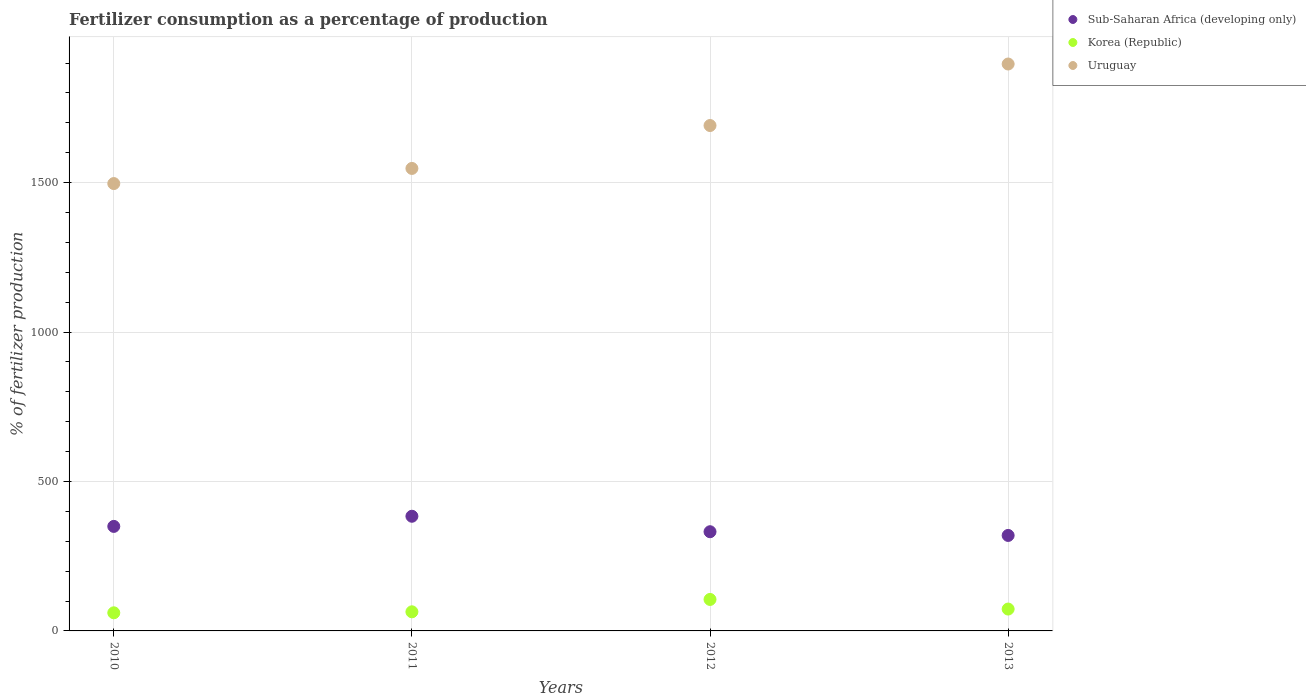Is the number of dotlines equal to the number of legend labels?
Provide a succinct answer. Yes. What is the percentage of fertilizers consumed in Sub-Saharan Africa (developing only) in 2010?
Your response must be concise. 349.74. Across all years, what is the maximum percentage of fertilizers consumed in Korea (Republic)?
Provide a short and direct response. 105.33. Across all years, what is the minimum percentage of fertilizers consumed in Uruguay?
Your response must be concise. 1496.86. In which year was the percentage of fertilizers consumed in Sub-Saharan Africa (developing only) maximum?
Offer a very short reply. 2011. What is the total percentage of fertilizers consumed in Korea (Republic) in the graph?
Your answer should be compact. 303.06. What is the difference between the percentage of fertilizers consumed in Sub-Saharan Africa (developing only) in 2011 and that in 2013?
Provide a succinct answer. 64.2. What is the difference between the percentage of fertilizers consumed in Korea (Republic) in 2013 and the percentage of fertilizers consumed in Sub-Saharan Africa (developing only) in 2012?
Offer a very short reply. -258.73. What is the average percentage of fertilizers consumed in Sub-Saharan Africa (developing only) per year?
Your response must be concise. 346.2. In the year 2010, what is the difference between the percentage of fertilizers consumed in Sub-Saharan Africa (developing only) and percentage of fertilizers consumed in Korea (Republic)?
Give a very brief answer. 289.13. What is the ratio of the percentage of fertilizers consumed in Korea (Republic) in 2010 to that in 2012?
Your answer should be compact. 0.58. Is the percentage of fertilizers consumed in Sub-Saharan Africa (developing only) in 2010 less than that in 2012?
Make the answer very short. No. What is the difference between the highest and the second highest percentage of fertilizers consumed in Sub-Saharan Africa (developing only)?
Your answer should be compact. 33.94. What is the difference between the highest and the lowest percentage of fertilizers consumed in Uruguay?
Provide a succinct answer. 400.01. In how many years, is the percentage of fertilizers consumed in Korea (Republic) greater than the average percentage of fertilizers consumed in Korea (Republic) taken over all years?
Give a very brief answer. 1. Does the percentage of fertilizers consumed in Korea (Republic) monotonically increase over the years?
Keep it short and to the point. No. Is the percentage of fertilizers consumed in Korea (Republic) strictly greater than the percentage of fertilizers consumed in Sub-Saharan Africa (developing only) over the years?
Provide a succinct answer. No. How many dotlines are there?
Ensure brevity in your answer.  3. How many years are there in the graph?
Offer a very short reply. 4. What is the difference between two consecutive major ticks on the Y-axis?
Provide a short and direct response. 500. Are the values on the major ticks of Y-axis written in scientific E-notation?
Your answer should be compact. No. Does the graph contain any zero values?
Provide a succinct answer. No. How are the legend labels stacked?
Offer a terse response. Vertical. What is the title of the graph?
Provide a succinct answer. Fertilizer consumption as a percentage of production. What is the label or title of the X-axis?
Your response must be concise. Years. What is the label or title of the Y-axis?
Your answer should be very brief. % of fertilizer production. What is the % of fertilizer production of Sub-Saharan Africa (developing only) in 2010?
Offer a very short reply. 349.74. What is the % of fertilizer production of Korea (Republic) in 2010?
Offer a very short reply. 60.61. What is the % of fertilizer production of Uruguay in 2010?
Ensure brevity in your answer.  1496.86. What is the % of fertilizer production in Sub-Saharan Africa (developing only) in 2011?
Ensure brevity in your answer.  383.68. What is the % of fertilizer production in Korea (Republic) in 2011?
Offer a terse response. 63.95. What is the % of fertilizer production in Uruguay in 2011?
Your answer should be compact. 1547.47. What is the % of fertilizer production of Sub-Saharan Africa (developing only) in 2012?
Provide a succinct answer. 331.91. What is the % of fertilizer production of Korea (Republic) in 2012?
Your answer should be very brief. 105.33. What is the % of fertilizer production of Uruguay in 2012?
Provide a short and direct response. 1691.07. What is the % of fertilizer production in Sub-Saharan Africa (developing only) in 2013?
Your answer should be very brief. 319.48. What is the % of fertilizer production of Korea (Republic) in 2013?
Give a very brief answer. 73.17. What is the % of fertilizer production in Uruguay in 2013?
Your answer should be very brief. 1896.87. Across all years, what is the maximum % of fertilizer production of Sub-Saharan Africa (developing only)?
Offer a very short reply. 383.68. Across all years, what is the maximum % of fertilizer production in Korea (Republic)?
Give a very brief answer. 105.33. Across all years, what is the maximum % of fertilizer production in Uruguay?
Offer a terse response. 1896.87. Across all years, what is the minimum % of fertilizer production of Sub-Saharan Africa (developing only)?
Your answer should be very brief. 319.48. Across all years, what is the minimum % of fertilizer production in Korea (Republic)?
Provide a short and direct response. 60.61. Across all years, what is the minimum % of fertilizer production of Uruguay?
Offer a very short reply. 1496.86. What is the total % of fertilizer production in Sub-Saharan Africa (developing only) in the graph?
Make the answer very short. 1384.8. What is the total % of fertilizer production in Korea (Republic) in the graph?
Ensure brevity in your answer.  303.06. What is the total % of fertilizer production of Uruguay in the graph?
Make the answer very short. 6632.26. What is the difference between the % of fertilizer production in Sub-Saharan Africa (developing only) in 2010 and that in 2011?
Provide a short and direct response. -33.94. What is the difference between the % of fertilizer production in Korea (Republic) in 2010 and that in 2011?
Offer a very short reply. -3.34. What is the difference between the % of fertilizer production of Uruguay in 2010 and that in 2011?
Offer a terse response. -50.62. What is the difference between the % of fertilizer production of Sub-Saharan Africa (developing only) in 2010 and that in 2012?
Your answer should be compact. 17.83. What is the difference between the % of fertilizer production in Korea (Republic) in 2010 and that in 2012?
Your answer should be compact. -44.72. What is the difference between the % of fertilizer production of Uruguay in 2010 and that in 2012?
Keep it short and to the point. -194.21. What is the difference between the % of fertilizer production of Sub-Saharan Africa (developing only) in 2010 and that in 2013?
Offer a very short reply. 30.26. What is the difference between the % of fertilizer production in Korea (Republic) in 2010 and that in 2013?
Make the answer very short. -12.56. What is the difference between the % of fertilizer production in Uruguay in 2010 and that in 2013?
Your response must be concise. -400.01. What is the difference between the % of fertilizer production of Sub-Saharan Africa (developing only) in 2011 and that in 2012?
Offer a very short reply. 51.77. What is the difference between the % of fertilizer production of Korea (Republic) in 2011 and that in 2012?
Provide a succinct answer. -41.39. What is the difference between the % of fertilizer production in Uruguay in 2011 and that in 2012?
Offer a terse response. -143.59. What is the difference between the % of fertilizer production of Sub-Saharan Africa (developing only) in 2011 and that in 2013?
Your response must be concise. 64.2. What is the difference between the % of fertilizer production of Korea (Republic) in 2011 and that in 2013?
Provide a succinct answer. -9.23. What is the difference between the % of fertilizer production in Uruguay in 2011 and that in 2013?
Offer a very short reply. -349.39. What is the difference between the % of fertilizer production in Sub-Saharan Africa (developing only) in 2012 and that in 2013?
Keep it short and to the point. 12.43. What is the difference between the % of fertilizer production of Korea (Republic) in 2012 and that in 2013?
Keep it short and to the point. 32.16. What is the difference between the % of fertilizer production in Uruguay in 2012 and that in 2013?
Keep it short and to the point. -205.8. What is the difference between the % of fertilizer production of Sub-Saharan Africa (developing only) in 2010 and the % of fertilizer production of Korea (Republic) in 2011?
Your answer should be very brief. 285.79. What is the difference between the % of fertilizer production of Sub-Saharan Africa (developing only) in 2010 and the % of fertilizer production of Uruguay in 2011?
Offer a very short reply. -1197.74. What is the difference between the % of fertilizer production in Korea (Republic) in 2010 and the % of fertilizer production in Uruguay in 2011?
Give a very brief answer. -1486.87. What is the difference between the % of fertilizer production in Sub-Saharan Africa (developing only) in 2010 and the % of fertilizer production in Korea (Republic) in 2012?
Offer a very short reply. 244.4. What is the difference between the % of fertilizer production in Sub-Saharan Africa (developing only) in 2010 and the % of fertilizer production in Uruguay in 2012?
Make the answer very short. -1341.33. What is the difference between the % of fertilizer production in Korea (Republic) in 2010 and the % of fertilizer production in Uruguay in 2012?
Provide a short and direct response. -1630.46. What is the difference between the % of fertilizer production in Sub-Saharan Africa (developing only) in 2010 and the % of fertilizer production in Korea (Republic) in 2013?
Your answer should be very brief. 276.56. What is the difference between the % of fertilizer production in Sub-Saharan Africa (developing only) in 2010 and the % of fertilizer production in Uruguay in 2013?
Your answer should be compact. -1547.13. What is the difference between the % of fertilizer production of Korea (Republic) in 2010 and the % of fertilizer production of Uruguay in 2013?
Offer a terse response. -1836.26. What is the difference between the % of fertilizer production of Sub-Saharan Africa (developing only) in 2011 and the % of fertilizer production of Korea (Republic) in 2012?
Ensure brevity in your answer.  278.35. What is the difference between the % of fertilizer production of Sub-Saharan Africa (developing only) in 2011 and the % of fertilizer production of Uruguay in 2012?
Give a very brief answer. -1307.39. What is the difference between the % of fertilizer production of Korea (Republic) in 2011 and the % of fertilizer production of Uruguay in 2012?
Offer a very short reply. -1627.12. What is the difference between the % of fertilizer production of Sub-Saharan Africa (developing only) in 2011 and the % of fertilizer production of Korea (Republic) in 2013?
Keep it short and to the point. 310.5. What is the difference between the % of fertilizer production in Sub-Saharan Africa (developing only) in 2011 and the % of fertilizer production in Uruguay in 2013?
Offer a very short reply. -1513.19. What is the difference between the % of fertilizer production in Korea (Republic) in 2011 and the % of fertilizer production in Uruguay in 2013?
Offer a terse response. -1832.92. What is the difference between the % of fertilizer production of Sub-Saharan Africa (developing only) in 2012 and the % of fertilizer production of Korea (Republic) in 2013?
Offer a very short reply. 258.73. What is the difference between the % of fertilizer production of Sub-Saharan Africa (developing only) in 2012 and the % of fertilizer production of Uruguay in 2013?
Offer a terse response. -1564.96. What is the difference between the % of fertilizer production in Korea (Republic) in 2012 and the % of fertilizer production in Uruguay in 2013?
Keep it short and to the point. -1791.53. What is the average % of fertilizer production in Sub-Saharan Africa (developing only) per year?
Ensure brevity in your answer.  346.2. What is the average % of fertilizer production in Korea (Republic) per year?
Provide a short and direct response. 75.77. What is the average % of fertilizer production of Uruguay per year?
Give a very brief answer. 1658.07. In the year 2010, what is the difference between the % of fertilizer production of Sub-Saharan Africa (developing only) and % of fertilizer production of Korea (Republic)?
Your answer should be compact. 289.13. In the year 2010, what is the difference between the % of fertilizer production of Sub-Saharan Africa (developing only) and % of fertilizer production of Uruguay?
Offer a terse response. -1147.12. In the year 2010, what is the difference between the % of fertilizer production of Korea (Republic) and % of fertilizer production of Uruguay?
Offer a very short reply. -1436.25. In the year 2011, what is the difference between the % of fertilizer production of Sub-Saharan Africa (developing only) and % of fertilizer production of Korea (Republic)?
Ensure brevity in your answer.  319.73. In the year 2011, what is the difference between the % of fertilizer production in Sub-Saharan Africa (developing only) and % of fertilizer production in Uruguay?
Your response must be concise. -1163.8. In the year 2011, what is the difference between the % of fertilizer production in Korea (Republic) and % of fertilizer production in Uruguay?
Offer a very short reply. -1483.53. In the year 2012, what is the difference between the % of fertilizer production of Sub-Saharan Africa (developing only) and % of fertilizer production of Korea (Republic)?
Give a very brief answer. 226.58. In the year 2012, what is the difference between the % of fertilizer production in Sub-Saharan Africa (developing only) and % of fertilizer production in Uruguay?
Provide a succinct answer. -1359.16. In the year 2012, what is the difference between the % of fertilizer production of Korea (Republic) and % of fertilizer production of Uruguay?
Your response must be concise. -1585.73. In the year 2013, what is the difference between the % of fertilizer production of Sub-Saharan Africa (developing only) and % of fertilizer production of Korea (Republic)?
Keep it short and to the point. 246.3. In the year 2013, what is the difference between the % of fertilizer production of Sub-Saharan Africa (developing only) and % of fertilizer production of Uruguay?
Provide a succinct answer. -1577.39. In the year 2013, what is the difference between the % of fertilizer production of Korea (Republic) and % of fertilizer production of Uruguay?
Offer a very short reply. -1823.69. What is the ratio of the % of fertilizer production in Sub-Saharan Africa (developing only) in 2010 to that in 2011?
Ensure brevity in your answer.  0.91. What is the ratio of the % of fertilizer production of Korea (Republic) in 2010 to that in 2011?
Your response must be concise. 0.95. What is the ratio of the % of fertilizer production of Uruguay in 2010 to that in 2011?
Give a very brief answer. 0.97. What is the ratio of the % of fertilizer production in Sub-Saharan Africa (developing only) in 2010 to that in 2012?
Your answer should be compact. 1.05. What is the ratio of the % of fertilizer production in Korea (Republic) in 2010 to that in 2012?
Offer a terse response. 0.58. What is the ratio of the % of fertilizer production in Uruguay in 2010 to that in 2012?
Ensure brevity in your answer.  0.89. What is the ratio of the % of fertilizer production of Sub-Saharan Africa (developing only) in 2010 to that in 2013?
Keep it short and to the point. 1.09. What is the ratio of the % of fertilizer production in Korea (Republic) in 2010 to that in 2013?
Your response must be concise. 0.83. What is the ratio of the % of fertilizer production in Uruguay in 2010 to that in 2013?
Keep it short and to the point. 0.79. What is the ratio of the % of fertilizer production of Sub-Saharan Africa (developing only) in 2011 to that in 2012?
Offer a terse response. 1.16. What is the ratio of the % of fertilizer production of Korea (Republic) in 2011 to that in 2012?
Provide a short and direct response. 0.61. What is the ratio of the % of fertilizer production in Uruguay in 2011 to that in 2012?
Provide a succinct answer. 0.92. What is the ratio of the % of fertilizer production in Sub-Saharan Africa (developing only) in 2011 to that in 2013?
Keep it short and to the point. 1.2. What is the ratio of the % of fertilizer production in Korea (Republic) in 2011 to that in 2013?
Provide a short and direct response. 0.87. What is the ratio of the % of fertilizer production in Uruguay in 2011 to that in 2013?
Provide a succinct answer. 0.82. What is the ratio of the % of fertilizer production of Sub-Saharan Africa (developing only) in 2012 to that in 2013?
Ensure brevity in your answer.  1.04. What is the ratio of the % of fertilizer production in Korea (Republic) in 2012 to that in 2013?
Your response must be concise. 1.44. What is the ratio of the % of fertilizer production in Uruguay in 2012 to that in 2013?
Offer a very short reply. 0.89. What is the difference between the highest and the second highest % of fertilizer production of Sub-Saharan Africa (developing only)?
Your answer should be compact. 33.94. What is the difference between the highest and the second highest % of fertilizer production of Korea (Republic)?
Your response must be concise. 32.16. What is the difference between the highest and the second highest % of fertilizer production of Uruguay?
Provide a short and direct response. 205.8. What is the difference between the highest and the lowest % of fertilizer production in Sub-Saharan Africa (developing only)?
Your answer should be compact. 64.2. What is the difference between the highest and the lowest % of fertilizer production in Korea (Republic)?
Ensure brevity in your answer.  44.72. What is the difference between the highest and the lowest % of fertilizer production of Uruguay?
Your response must be concise. 400.01. 